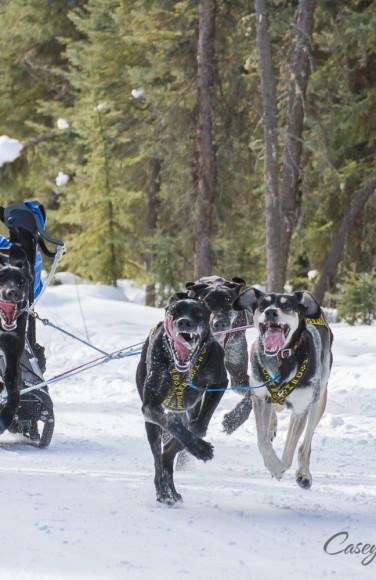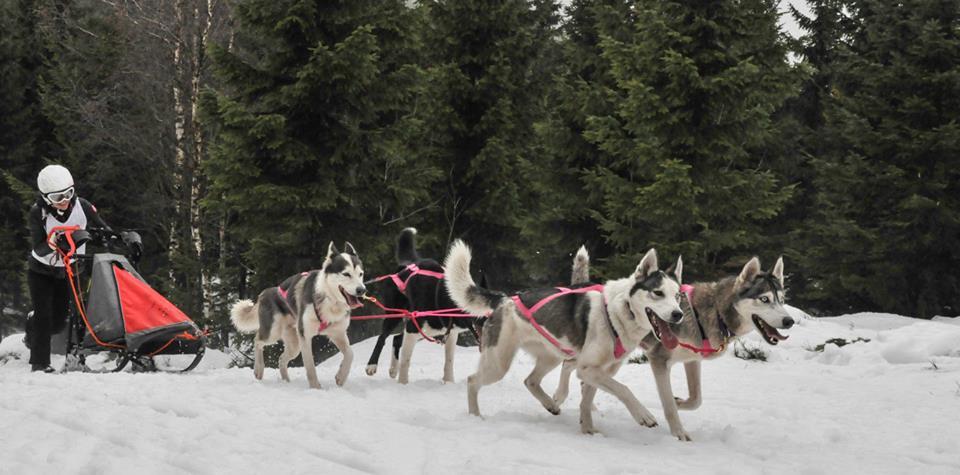The first image is the image on the left, the second image is the image on the right. Examine the images to the left and right. Is the description "Someone is riding a bike while dogs run with them." accurate? Answer yes or no. No. The first image is the image on the left, the second image is the image on the right. Analyze the images presented: Is the assertion "At least one image shows sled dogs moving across a snowy ground." valid? Answer yes or no. Yes. 